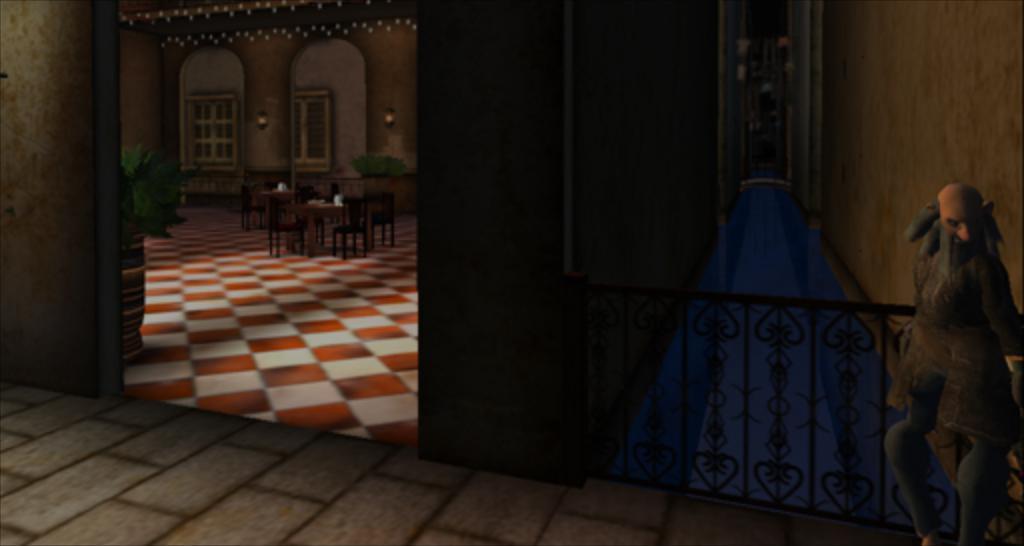Describe this image in one or two sentences. In this image I can see the statue of the person. To the side of the statue I can see the railing. To the left I can see the many tables and chairs. I can also see the plant to the side. In the background I can see some lights to the wall. 